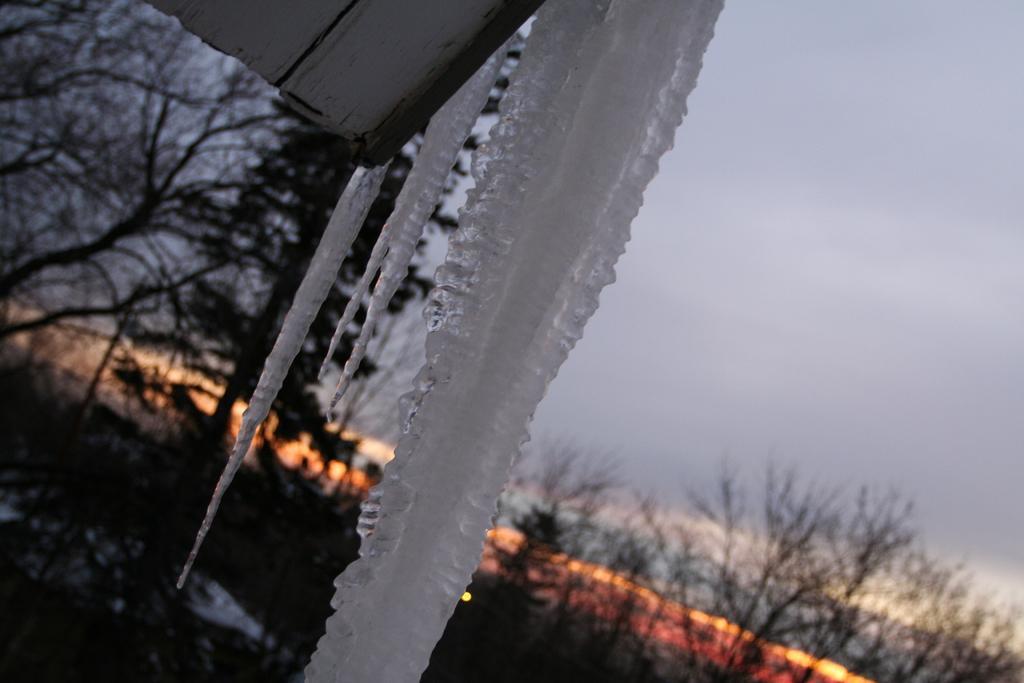Can you describe this image briefly? In this image I can see an ice, background I can see few dried trees and the sky is in white and orange color. 